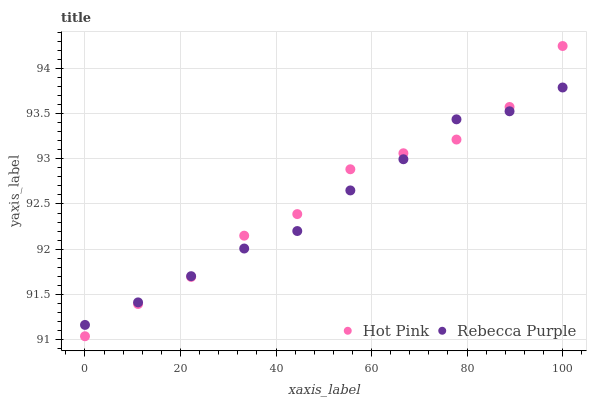Does Rebecca Purple have the minimum area under the curve?
Answer yes or no. Yes. Does Hot Pink have the maximum area under the curve?
Answer yes or no. Yes. Does Rebecca Purple have the maximum area under the curve?
Answer yes or no. No. Is Rebecca Purple the smoothest?
Answer yes or no. Yes. Is Hot Pink the roughest?
Answer yes or no. Yes. Is Rebecca Purple the roughest?
Answer yes or no. No. Does Hot Pink have the lowest value?
Answer yes or no. Yes. Does Rebecca Purple have the lowest value?
Answer yes or no. No. Does Hot Pink have the highest value?
Answer yes or no. Yes. Does Rebecca Purple have the highest value?
Answer yes or no. No. Does Rebecca Purple intersect Hot Pink?
Answer yes or no. Yes. Is Rebecca Purple less than Hot Pink?
Answer yes or no. No. Is Rebecca Purple greater than Hot Pink?
Answer yes or no. No. 